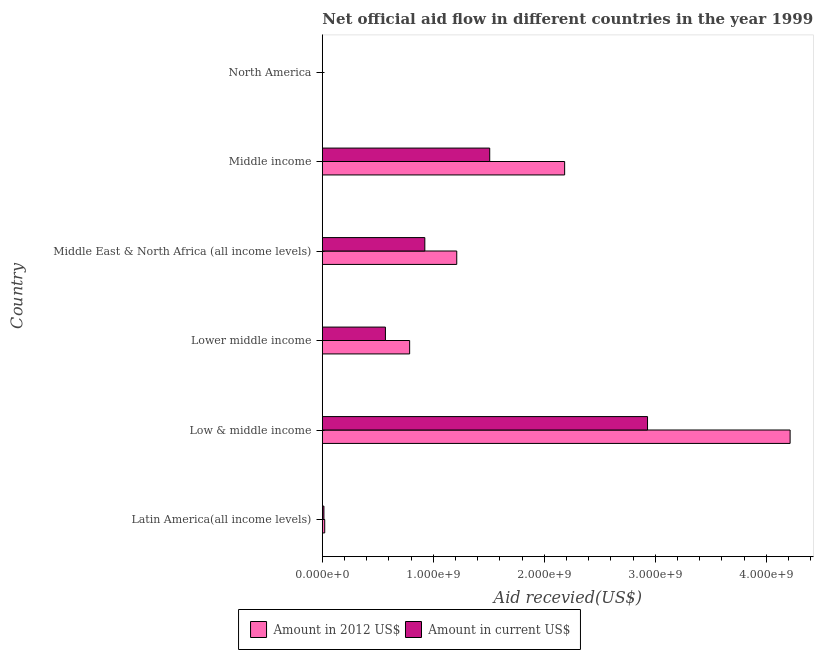How many different coloured bars are there?
Your answer should be compact. 2. How many groups of bars are there?
Provide a short and direct response. 6. Are the number of bars on each tick of the Y-axis equal?
Your answer should be very brief. Yes. What is the label of the 6th group of bars from the top?
Make the answer very short. Latin America(all income levels). In how many cases, is the number of bars for a given country not equal to the number of legend labels?
Make the answer very short. 0. What is the amount of aid received(expressed in us$) in Latin America(all income levels)?
Make the answer very short. 1.43e+07. Across all countries, what is the maximum amount of aid received(expressed in 2012 us$)?
Provide a succinct answer. 4.22e+09. Across all countries, what is the minimum amount of aid received(expressed in 2012 us$)?
Keep it short and to the point. 1.30e+05. What is the total amount of aid received(expressed in us$) in the graph?
Your answer should be very brief. 5.95e+09. What is the difference between the amount of aid received(expressed in 2012 us$) in Low & middle income and that in Middle East & North Africa (all income levels)?
Make the answer very short. 3.00e+09. What is the difference between the amount of aid received(expressed in us$) in Middle East & North Africa (all income levels) and the amount of aid received(expressed in 2012 us$) in North America?
Offer a terse response. 9.24e+08. What is the average amount of aid received(expressed in 2012 us$) per country?
Your answer should be very brief. 1.40e+09. What is the difference between the amount of aid received(expressed in us$) and amount of aid received(expressed in 2012 us$) in Middle East & North Africa (all income levels)?
Give a very brief answer. -2.88e+08. In how many countries, is the amount of aid received(expressed in 2012 us$) greater than 600000000 US$?
Ensure brevity in your answer.  4. What is the ratio of the amount of aid received(expressed in us$) in Lower middle income to that in Middle income?
Your response must be concise. 0.38. Is the difference between the amount of aid received(expressed in 2012 us$) in Middle East & North Africa (all income levels) and North America greater than the difference between the amount of aid received(expressed in us$) in Middle East & North Africa (all income levels) and North America?
Provide a short and direct response. Yes. What is the difference between the highest and the second highest amount of aid received(expressed in us$)?
Your response must be concise. 1.42e+09. What is the difference between the highest and the lowest amount of aid received(expressed in us$)?
Give a very brief answer. 2.93e+09. What does the 2nd bar from the top in Low & middle income represents?
Offer a very short reply. Amount in 2012 US$. What does the 1st bar from the bottom in North America represents?
Keep it short and to the point. Amount in 2012 US$. Are all the bars in the graph horizontal?
Keep it short and to the point. Yes. How many countries are there in the graph?
Ensure brevity in your answer.  6. What is the difference between two consecutive major ticks on the X-axis?
Your response must be concise. 1.00e+09. Are the values on the major ticks of X-axis written in scientific E-notation?
Provide a short and direct response. Yes. Does the graph contain grids?
Offer a very short reply. No. How are the legend labels stacked?
Ensure brevity in your answer.  Horizontal. What is the title of the graph?
Your answer should be compact. Net official aid flow in different countries in the year 1999. What is the label or title of the X-axis?
Offer a very short reply. Aid recevied(US$). What is the label or title of the Y-axis?
Offer a terse response. Country. What is the Aid recevied(US$) of Amount in 2012 US$ in Latin America(all income levels)?
Keep it short and to the point. 2.15e+07. What is the Aid recevied(US$) in Amount in current US$ in Latin America(all income levels)?
Offer a terse response. 1.43e+07. What is the Aid recevied(US$) of Amount in 2012 US$ in Low & middle income?
Provide a succinct answer. 4.22e+09. What is the Aid recevied(US$) of Amount in current US$ in Low & middle income?
Provide a short and direct response. 2.93e+09. What is the Aid recevied(US$) of Amount in 2012 US$ in Lower middle income?
Your response must be concise. 7.87e+08. What is the Aid recevied(US$) in Amount in current US$ in Lower middle income?
Your answer should be compact. 5.69e+08. What is the Aid recevied(US$) in Amount in 2012 US$ in Middle East & North Africa (all income levels)?
Your answer should be compact. 1.21e+09. What is the Aid recevied(US$) of Amount in current US$ in Middle East & North Africa (all income levels)?
Offer a terse response. 9.24e+08. What is the Aid recevied(US$) in Amount in 2012 US$ in Middle income?
Keep it short and to the point. 2.18e+09. What is the Aid recevied(US$) in Amount in current US$ in Middle income?
Provide a short and direct response. 1.51e+09. What is the Aid recevied(US$) in Amount in current US$ in North America?
Keep it short and to the point. 8.00e+04. Across all countries, what is the maximum Aid recevied(US$) in Amount in 2012 US$?
Keep it short and to the point. 4.22e+09. Across all countries, what is the maximum Aid recevied(US$) of Amount in current US$?
Offer a terse response. 2.93e+09. Across all countries, what is the minimum Aid recevied(US$) of Amount in 2012 US$?
Your answer should be compact. 1.30e+05. What is the total Aid recevied(US$) in Amount in 2012 US$ in the graph?
Your answer should be very brief. 8.42e+09. What is the total Aid recevied(US$) in Amount in current US$ in the graph?
Ensure brevity in your answer.  5.95e+09. What is the difference between the Aid recevied(US$) in Amount in 2012 US$ in Latin America(all income levels) and that in Low & middle income?
Make the answer very short. -4.19e+09. What is the difference between the Aid recevied(US$) of Amount in current US$ in Latin America(all income levels) and that in Low & middle income?
Provide a short and direct response. -2.92e+09. What is the difference between the Aid recevied(US$) of Amount in 2012 US$ in Latin America(all income levels) and that in Lower middle income?
Offer a terse response. -7.65e+08. What is the difference between the Aid recevied(US$) in Amount in current US$ in Latin America(all income levels) and that in Lower middle income?
Provide a short and direct response. -5.54e+08. What is the difference between the Aid recevied(US$) in Amount in 2012 US$ in Latin America(all income levels) and that in Middle East & North Africa (all income levels)?
Ensure brevity in your answer.  -1.19e+09. What is the difference between the Aid recevied(US$) of Amount in current US$ in Latin America(all income levels) and that in Middle East & North Africa (all income levels)?
Provide a succinct answer. -9.09e+08. What is the difference between the Aid recevied(US$) in Amount in 2012 US$ in Latin America(all income levels) and that in Middle income?
Offer a terse response. -2.16e+09. What is the difference between the Aid recevied(US$) of Amount in current US$ in Latin America(all income levels) and that in Middle income?
Ensure brevity in your answer.  -1.49e+09. What is the difference between the Aid recevied(US$) in Amount in 2012 US$ in Latin America(all income levels) and that in North America?
Your answer should be very brief. 2.14e+07. What is the difference between the Aid recevied(US$) in Amount in current US$ in Latin America(all income levels) and that in North America?
Make the answer very short. 1.42e+07. What is the difference between the Aid recevied(US$) in Amount in 2012 US$ in Low & middle income and that in Lower middle income?
Keep it short and to the point. 3.43e+09. What is the difference between the Aid recevied(US$) of Amount in current US$ in Low & middle income and that in Lower middle income?
Your answer should be very brief. 2.36e+09. What is the difference between the Aid recevied(US$) of Amount in 2012 US$ in Low & middle income and that in Middle East & North Africa (all income levels)?
Give a very brief answer. 3.00e+09. What is the difference between the Aid recevied(US$) of Amount in current US$ in Low & middle income and that in Middle East & North Africa (all income levels)?
Make the answer very short. 2.01e+09. What is the difference between the Aid recevied(US$) in Amount in 2012 US$ in Low & middle income and that in Middle income?
Give a very brief answer. 2.03e+09. What is the difference between the Aid recevied(US$) of Amount in current US$ in Low & middle income and that in Middle income?
Provide a short and direct response. 1.42e+09. What is the difference between the Aid recevied(US$) in Amount in 2012 US$ in Low & middle income and that in North America?
Give a very brief answer. 4.22e+09. What is the difference between the Aid recevied(US$) of Amount in current US$ in Low & middle income and that in North America?
Ensure brevity in your answer.  2.93e+09. What is the difference between the Aid recevied(US$) of Amount in 2012 US$ in Lower middle income and that in Middle East & North Africa (all income levels)?
Provide a succinct answer. -4.24e+08. What is the difference between the Aid recevied(US$) in Amount in current US$ in Lower middle income and that in Middle East & North Africa (all income levels)?
Your answer should be very brief. -3.55e+08. What is the difference between the Aid recevied(US$) of Amount in 2012 US$ in Lower middle income and that in Middle income?
Offer a terse response. -1.40e+09. What is the difference between the Aid recevied(US$) in Amount in current US$ in Lower middle income and that in Middle income?
Ensure brevity in your answer.  -9.40e+08. What is the difference between the Aid recevied(US$) of Amount in 2012 US$ in Lower middle income and that in North America?
Ensure brevity in your answer.  7.87e+08. What is the difference between the Aid recevied(US$) of Amount in current US$ in Lower middle income and that in North America?
Offer a terse response. 5.68e+08. What is the difference between the Aid recevied(US$) in Amount in 2012 US$ in Middle East & North Africa (all income levels) and that in Middle income?
Offer a very short reply. -9.72e+08. What is the difference between the Aid recevied(US$) in Amount in current US$ in Middle East & North Africa (all income levels) and that in Middle income?
Offer a very short reply. -5.85e+08. What is the difference between the Aid recevied(US$) of Amount in 2012 US$ in Middle East & North Africa (all income levels) and that in North America?
Your answer should be very brief. 1.21e+09. What is the difference between the Aid recevied(US$) in Amount in current US$ in Middle East & North Africa (all income levels) and that in North America?
Your answer should be compact. 9.24e+08. What is the difference between the Aid recevied(US$) in Amount in 2012 US$ in Middle income and that in North America?
Your response must be concise. 2.18e+09. What is the difference between the Aid recevied(US$) in Amount in current US$ in Middle income and that in North America?
Provide a short and direct response. 1.51e+09. What is the difference between the Aid recevied(US$) of Amount in 2012 US$ in Latin America(all income levels) and the Aid recevied(US$) of Amount in current US$ in Low & middle income?
Ensure brevity in your answer.  -2.91e+09. What is the difference between the Aid recevied(US$) of Amount in 2012 US$ in Latin America(all income levels) and the Aid recevied(US$) of Amount in current US$ in Lower middle income?
Give a very brief answer. -5.47e+08. What is the difference between the Aid recevied(US$) of Amount in 2012 US$ in Latin America(all income levels) and the Aid recevied(US$) of Amount in current US$ in Middle East & North Africa (all income levels)?
Your answer should be very brief. -9.02e+08. What is the difference between the Aid recevied(US$) in Amount in 2012 US$ in Latin America(all income levels) and the Aid recevied(US$) in Amount in current US$ in Middle income?
Keep it short and to the point. -1.49e+09. What is the difference between the Aid recevied(US$) of Amount in 2012 US$ in Latin America(all income levels) and the Aid recevied(US$) of Amount in current US$ in North America?
Keep it short and to the point. 2.14e+07. What is the difference between the Aid recevied(US$) in Amount in 2012 US$ in Low & middle income and the Aid recevied(US$) in Amount in current US$ in Lower middle income?
Provide a short and direct response. 3.65e+09. What is the difference between the Aid recevied(US$) of Amount in 2012 US$ in Low & middle income and the Aid recevied(US$) of Amount in current US$ in Middle East & North Africa (all income levels)?
Offer a very short reply. 3.29e+09. What is the difference between the Aid recevied(US$) in Amount in 2012 US$ in Low & middle income and the Aid recevied(US$) in Amount in current US$ in Middle income?
Provide a short and direct response. 2.71e+09. What is the difference between the Aid recevied(US$) in Amount in 2012 US$ in Low & middle income and the Aid recevied(US$) in Amount in current US$ in North America?
Make the answer very short. 4.22e+09. What is the difference between the Aid recevied(US$) of Amount in 2012 US$ in Lower middle income and the Aid recevied(US$) of Amount in current US$ in Middle East & North Africa (all income levels)?
Offer a very short reply. -1.37e+08. What is the difference between the Aid recevied(US$) in Amount in 2012 US$ in Lower middle income and the Aid recevied(US$) in Amount in current US$ in Middle income?
Provide a short and direct response. -7.22e+08. What is the difference between the Aid recevied(US$) in Amount in 2012 US$ in Lower middle income and the Aid recevied(US$) in Amount in current US$ in North America?
Offer a very short reply. 7.87e+08. What is the difference between the Aid recevied(US$) of Amount in 2012 US$ in Middle East & North Africa (all income levels) and the Aid recevied(US$) of Amount in current US$ in Middle income?
Make the answer very short. -2.97e+08. What is the difference between the Aid recevied(US$) of Amount in 2012 US$ in Middle East & North Africa (all income levels) and the Aid recevied(US$) of Amount in current US$ in North America?
Keep it short and to the point. 1.21e+09. What is the difference between the Aid recevied(US$) in Amount in 2012 US$ in Middle income and the Aid recevied(US$) in Amount in current US$ in North America?
Your response must be concise. 2.18e+09. What is the average Aid recevied(US$) of Amount in 2012 US$ per country?
Your answer should be compact. 1.40e+09. What is the average Aid recevied(US$) in Amount in current US$ per country?
Your answer should be compact. 9.91e+08. What is the difference between the Aid recevied(US$) in Amount in 2012 US$ and Aid recevied(US$) in Amount in current US$ in Latin America(all income levels)?
Provide a succinct answer. 7.17e+06. What is the difference between the Aid recevied(US$) in Amount in 2012 US$ and Aid recevied(US$) in Amount in current US$ in Low & middle income?
Your response must be concise. 1.28e+09. What is the difference between the Aid recevied(US$) in Amount in 2012 US$ and Aid recevied(US$) in Amount in current US$ in Lower middle income?
Your response must be concise. 2.18e+08. What is the difference between the Aid recevied(US$) of Amount in 2012 US$ and Aid recevied(US$) of Amount in current US$ in Middle East & North Africa (all income levels)?
Provide a succinct answer. 2.88e+08. What is the difference between the Aid recevied(US$) in Amount in 2012 US$ and Aid recevied(US$) in Amount in current US$ in Middle income?
Provide a succinct answer. 6.75e+08. What is the ratio of the Aid recevied(US$) in Amount in 2012 US$ in Latin America(all income levels) to that in Low & middle income?
Your answer should be compact. 0.01. What is the ratio of the Aid recevied(US$) of Amount in current US$ in Latin America(all income levels) to that in Low & middle income?
Give a very brief answer. 0. What is the ratio of the Aid recevied(US$) of Amount in 2012 US$ in Latin America(all income levels) to that in Lower middle income?
Give a very brief answer. 0.03. What is the ratio of the Aid recevied(US$) of Amount in current US$ in Latin America(all income levels) to that in Lower middle income?
Provide a short and direct response. 0.03. What is the ratio of the Aid recevied(US$) of Amount in 2012 US$ in Latin America(all income levels) to that in Middle East & North Africa (all income levels)?
Provide a succinct answer. 0.02. What is the ratio of the Aid recevied(US$) in Amount in current US$ in Latin America(all income levels) to that in Middle East & North Africa (all income levels)?
Your answer should be compact. 0.02. What is the ratio of the Aid recevied(US$) in Amount in 2012 US$ in Latin America(all income levels) to that in Middle income?
Give a very brief answer. 0.01. What is the ratio of the Aid recevied(US$) of Amount in current US$ in Latin America(all income levels) to that in Middle income?
Your response must be concise. 0.01. What is the ratio of the Aid recevied(US$) of Amount in 2012 US$ in Latin America(all income levels) to that in North America?
Provide a short and direct response. 165.38. What is the ratio of the Aid recevied(US$) of Amount in current US$ in Latin America(all income levels) to that in North America?
Ensure brevity in your answer.  179.12. What is the ratio of the Aid recevied(US$) in Amount in 2012 US$ in Low & middle income to that in Lower middle income?
Your answer should be very brief. 5.36. What is the ratio of the Aid recevied(US$) of Amount in current US$ in Low & middle income to that in Lower middle income?
Give a very brief answer. 5.15. What is the ratio of the Aid recevied(US$) in Amount in 2012 US$ in Low & middle income to that in Middle East & North Africa (all income levels)?
Give a very brief answer. 3.48. What is the ratio of the Aid recevied(US$) of Amount in current US$ in Low & middle income to that in Middle East & North Africa (all income levels)?
Provide a succinct answer. 3.17. What is the ratio of the Aid recevied(US$) in Amount in 2012 US$ in Low & middle income to that in Middle income?
Your answer should be compact. 1.93. What is the ratio of the Aid recevied(US$) of Amount in current US$ in Low & middle income to that in Middle income?
Your response must be concise. 1.94. What is the ratio of the Aid recevied(US$) in Amount in 2012 US$ in Low & middle income to that in North America?
Offer a terse response. 3.24e+04. What is the ratio of the Aid recevied(US$) in Amount in current US$ in Low & middle income to that in North America?
Provide a succinct answer. 3.66e+04. What is the ratio of the Aid recevied(US$) of Amount in 2012 US$ in Lower middle income to that in Middle East & North Africa (all income levels)?
Offer a terse response. 0.65. What is the ratio of the Aid recevied(US$) in Amount in current US$ in Lower middle income to that in Middle East & North Africa (all income levels)?
Provide a short and direct response. 0.62. What is the ratio of the Aid recevied(US$) in Amount in 2012 US$ in Lower middle income to that in Middle income?
Keep it short and to the point. 0.36. What is the ratio of the Aid recevied(US$) of Amount in current US$ in Lower middle income to that in Middle income?
Your answer should be compact. 0.38. What is the ratio of the Aid recevied(US$) of Amount in 2012 US$ in Lower middle income to that in North America?
Offer a very short reply. 6052.77. What is the ratio of the Aid recevied(US$) in Amount in current US$ in Lower middle income to that in North America?
Your answer should be very brief. 7107. What is the ratio of the Aid recevied(US$) in Amount in 2012 US$ in Middle East & North Africa (all income levels) to that in Middle income?
Your answer should be very brief. 0.55. What is the ratio of the Aid recevied(US$) in Amount in current US$ in Middle East & North Africa (all income levels) to that in Middle income?
Provide a succinct answer. 0.61. What is the ratio of the Aid recevied(US$) of Amount in 2012 US$ in Middle East & North Africa (all income levels) to that in North America?
Keep it short and to the point. 9318. What is the ratio of the Aid recevied(US$) of Amount in current US$ in Middle East & North Africa (all income levels) to that in North America?
Make the answer very short. 1.15e+04. What is the ratio of the Aid recevied(US$) in Amount in 2012 US$ in Middle income to that in North America?
Offer a terse response. 1.68e+04. What is the ratio of the Aid recevied(US$) in Amount in current US$ in Middle income to that in North America?
Your response must be concise. 1.89e+04. What is the difference between the highest and the second highest Aid recevied(US$) of Amount in 2012 US$?
Your answer should be very brief. 2.03e+09. What is the difference between the highest and the second highest Aid recevied(US$) in Amount in current US$?
Your answer should be compact. 1.42e+09. What is the difference between the highest and the lowest Aid recevied(US$) in Amount in 2012 US$?
Your answer should be compact. 4.22e+09. What is the difference between the highest and the lowest Aid recevied(US$) of Amount in current US$?
Your answer should be very brief. 2.93e+09. 